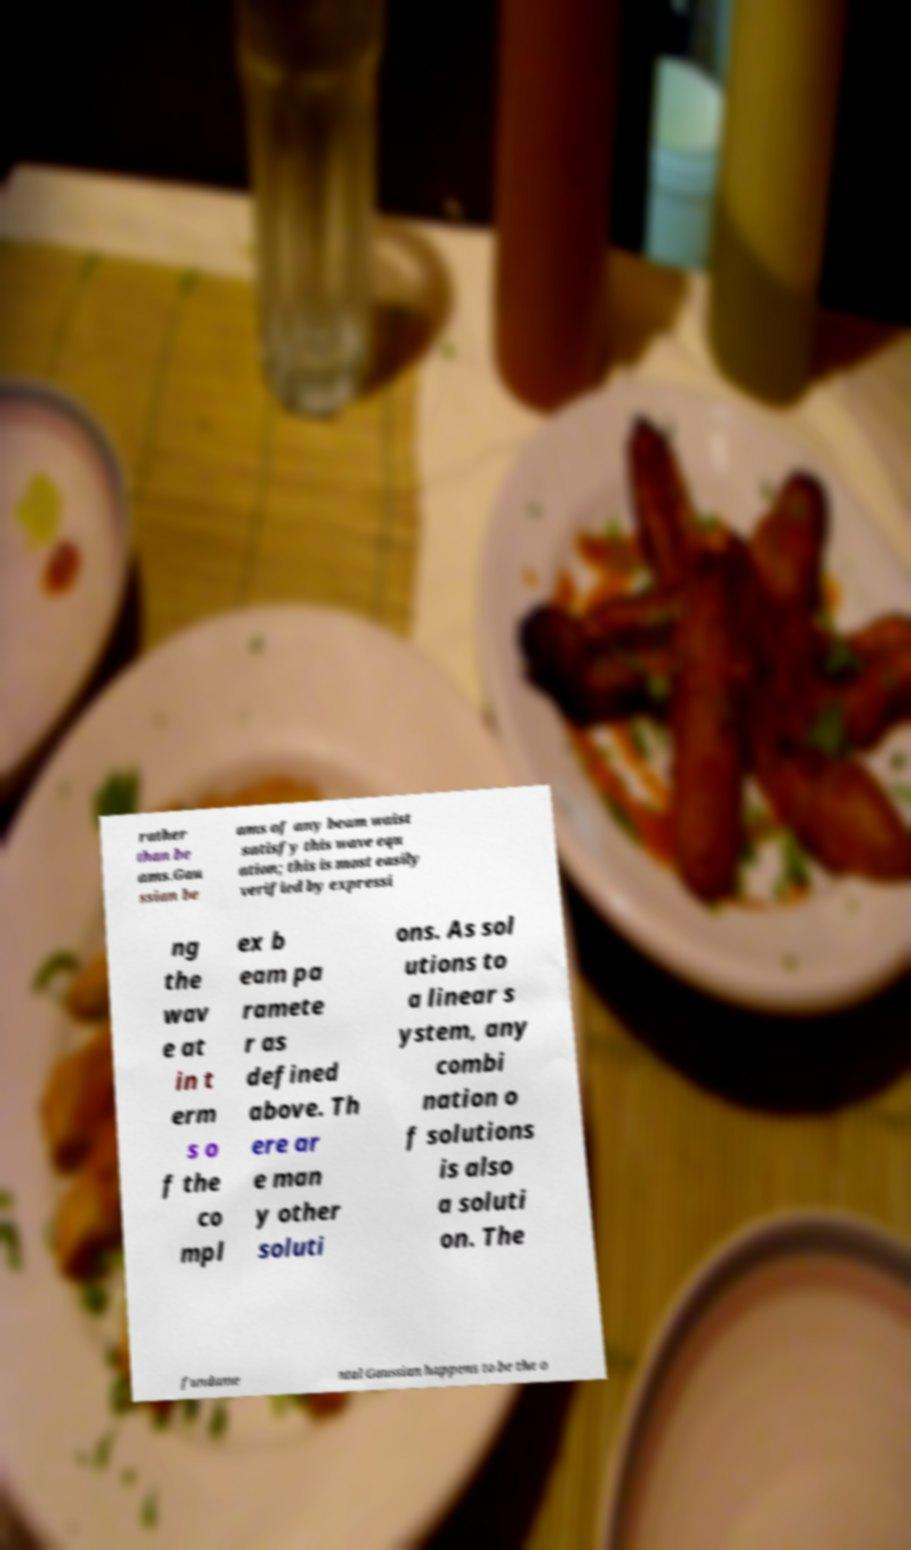Can you accurately transcribe the text from the provided image for me? rather than be ams.Gau ssian be ams of any beam waist satisfy this wave equ ation; this is most easily verified by expressi ng the wav e at in t erm s o f the co mpl ex b eam pa ramete r as defined above. Th ere ar e man y other soluti ons. As sol utions to a linear s ystem, any combi nation o f solutions is also a soluti on. The fundame ntal Gaussian happens to be the o 